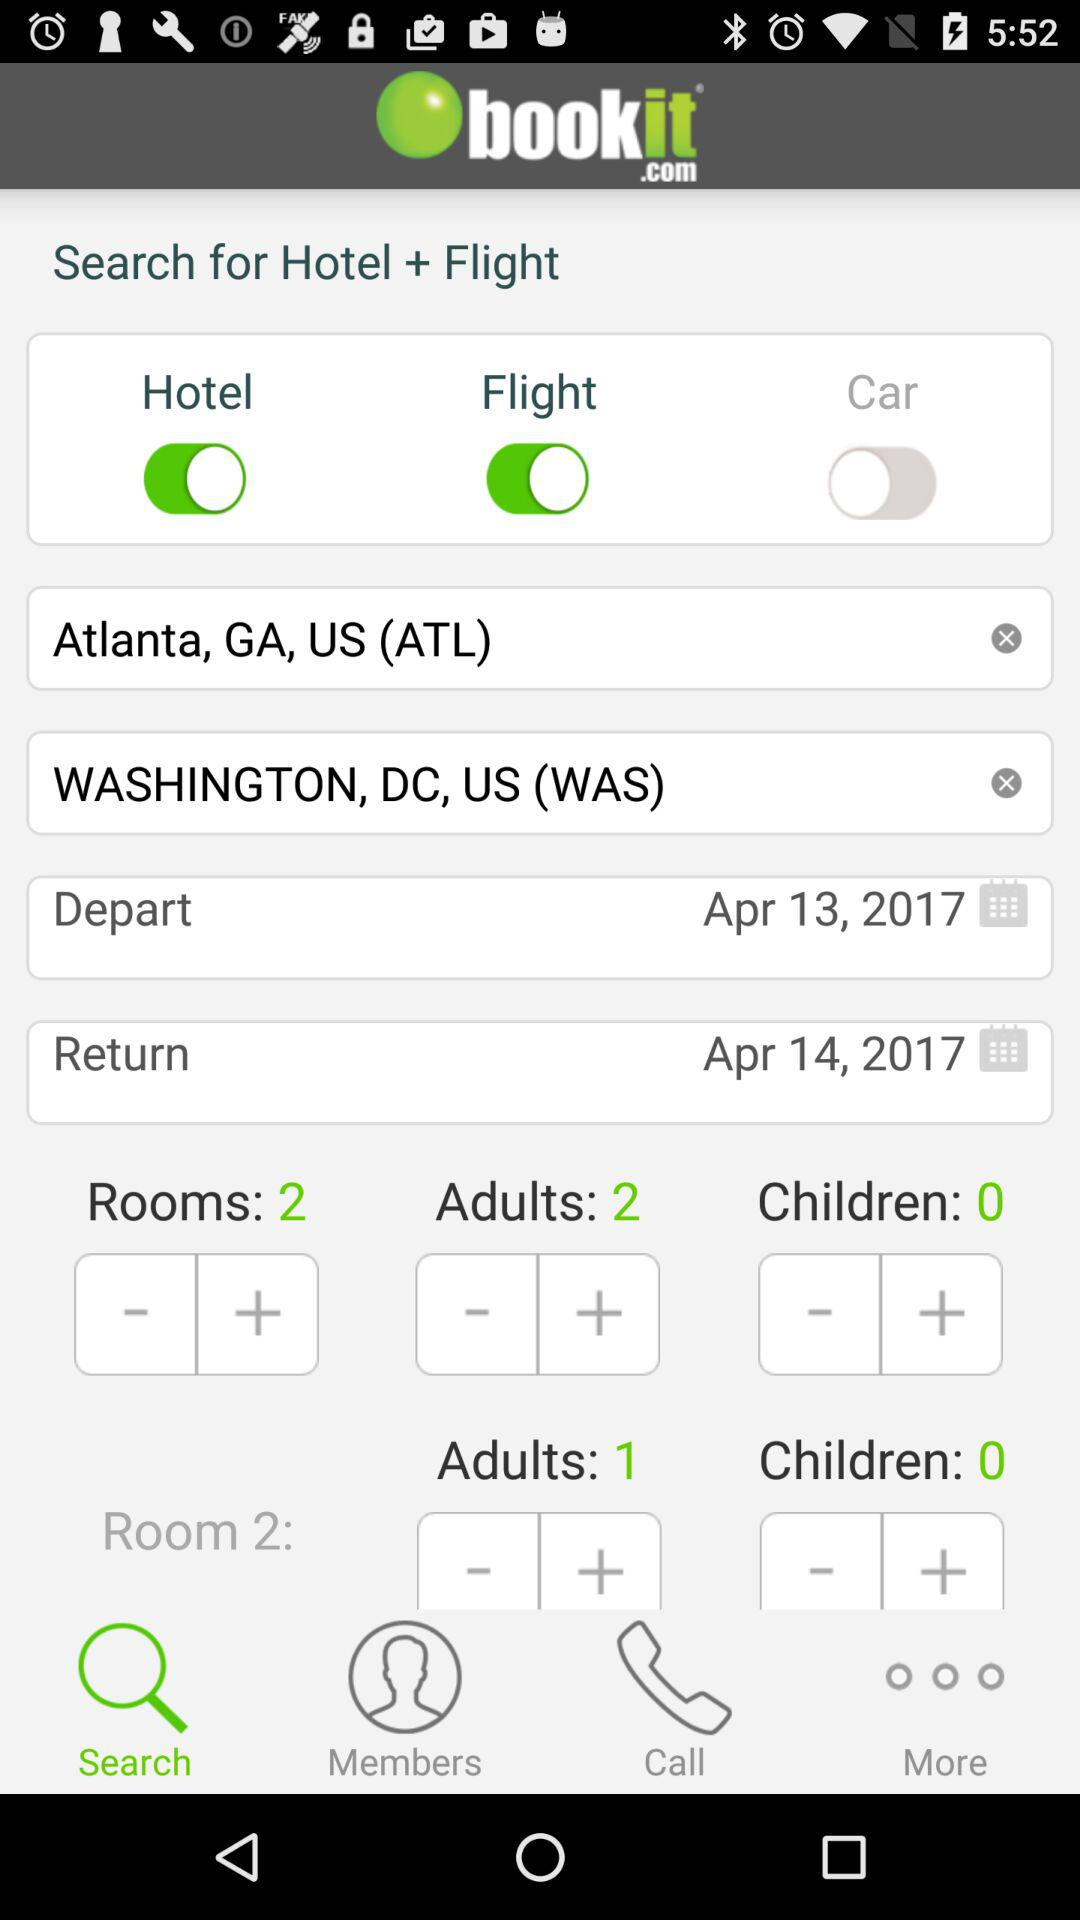What is the return date? The return date is April 14, 2017. 